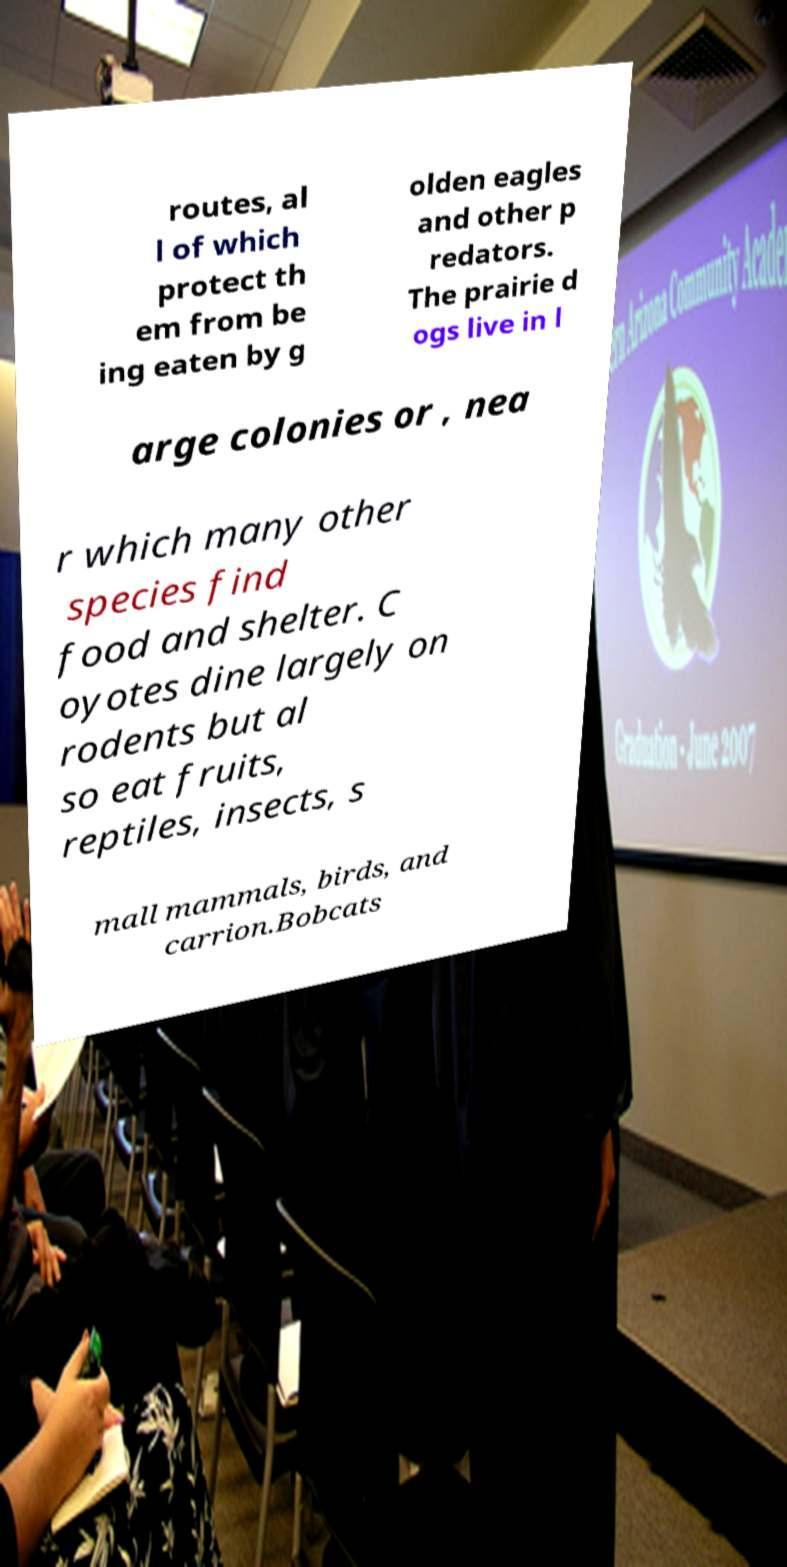There's text embedded in this image that I need extracted. Can you transcribe it verbatim? routes, al l of which protect th em from be ing eaten by g olden eagles and other p redators. The prairie d ogs live in l arge colonies or , nea r which many other species find food and shelter. C oyotes dine largely on rodents but al so eat fruits, reptiles, insects, s mall mammals, birds, and carrion.Bobcats 